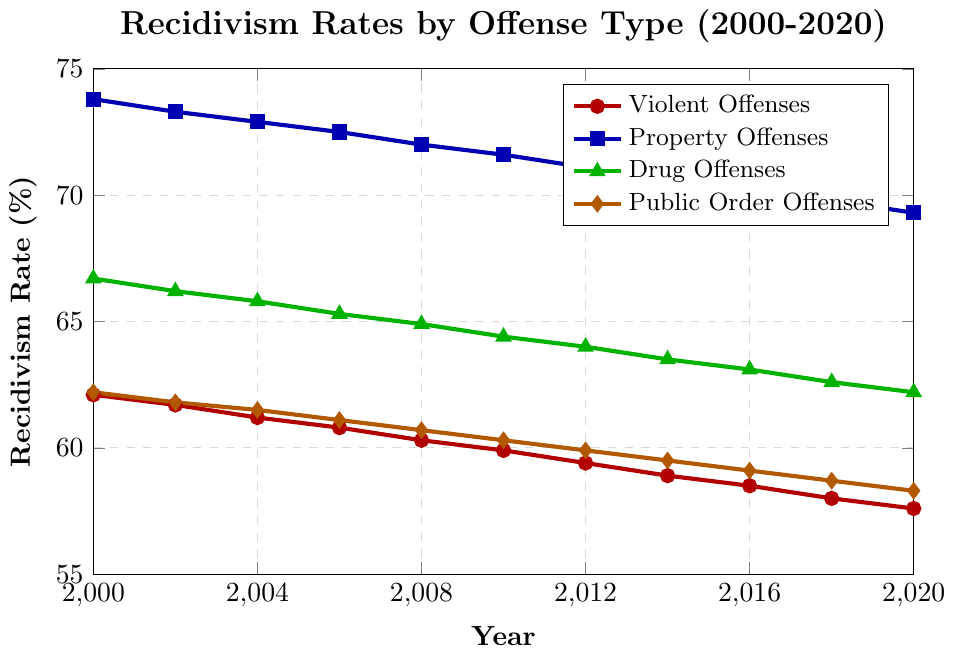What is the overall trend in recidivism rates for Violent Offenses from 2000 to 2020? From the figure, you can see that the recidivism rate for Violent Offenses decreases over time. In 2000, it is 62.1%, and in 2020, it is 57.6%. Thus, the overall trend is a decrease.
Answer: Decreasing Which type of offense saw the highest recidivism rate in 2000? By examining the starting points on the y-axis for all offense types in 2000, Property Offenses had the highest rate at 73.8%.
Answer: Property Offenses How much did the recidivism rate for Drug Offenses decrease from 2000 to 2020? The recidivism rate for Drug Offenses in 2000 was 66.7%, and in 2020 it was 62.2%. The decrease can be calculated as 66.7% - 62.2% = 4.5%.
Answer: 4.5% By what percentage did the recidivism rate for Public Order Offenses change from 2010 to 2020? The recidivism rate for Public Order Offenses was 60.3% in 2010 and 58.3% in 2020. The percentage change is calculated as ((60.3 - 58.3) / 60.3) * 100 ≈ 3.32%.
Answer: Approximately 3.32% Which type of offense has consistently had the lowest recidivism rate throughout 2000 to 2020? By observing all the lines in the figure, Public Order Offenses consistently has the lowest recidivism rate compared to other offense types in each year displayed.
Answer: Public Order Offenses In which year do Property Offenses and Drug Offenses have the smallest difference in recidivism rates? The smallest difference can be identified by calculating the absolute difference between Property Offenses and Drug Offenses for each year. In 2020, the difference is smallest as it is 69.3% - 62.2% = 7.1%.
Answer: 2020 What is the average recidivism rate for Violent Offenses over the three years 2000, 2010, and 2020? The recidivism rates for Violent Offenses in 2000, 2010, and 2020 are 62.1%, 59.9%, and 57.6%, respectively. The average is calculated as (62.1 + 59.9 + 57.6) / 3 ≈ 59.87%.
Answer: Approximately 59.87% Is there any year where the recidivism rate for Violent Offenses is higher than for Public Order Offenses? By inspecting the lines for Violent Offenses (red) and Public Order Offenses (orange), the red line remains slightly above the orange line in all years. Thus, the answer is yes.
Answer: Yes 